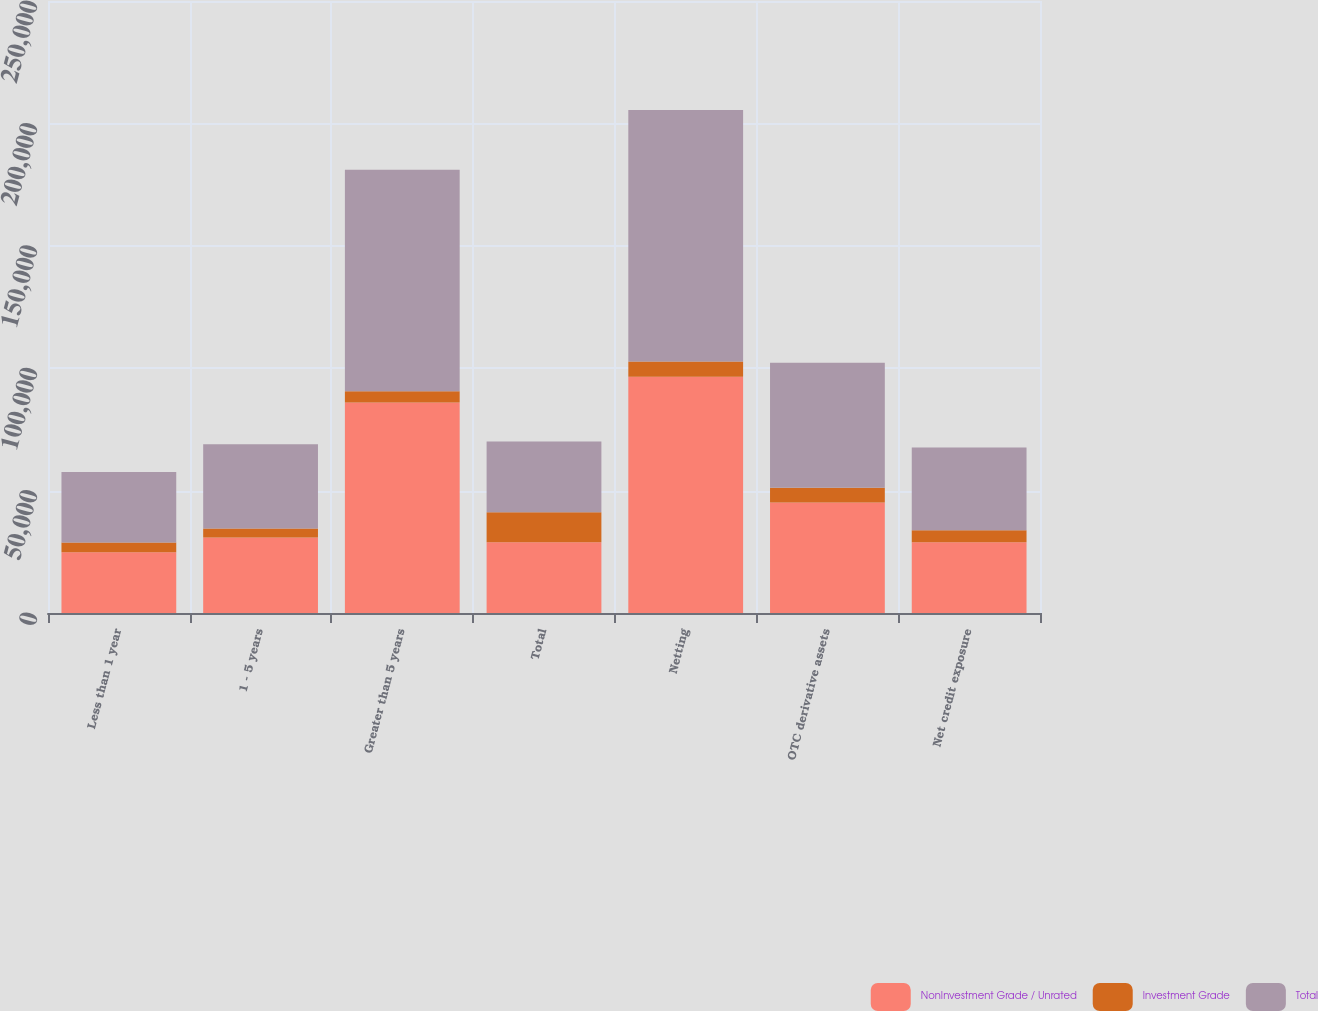Convert chart. <chart><loc_0><loc_0><loc_500><loc_500><stacked_bar_chart><ecel><fcel>Less than 1 year<fcel>1 - 5 years<fcel>Greater than 5 years<fcel>Total<fcel>Netting<fcel>OTC derivative assets<fcel>Net credit exposure<nl><fcel>NonInvestment Grade / Unrated<fcel>24840<fcel>30801<fcel>85951<fcel>28879<fcel>96493<fcel>45099<fcel>28879<nl><fcel>Investment Grade<fcel>3983<fcel>3676<fcel>4599<fcel>12258<fcel>6232<fcel>6026<fcel>4922<nl><fcel>Total<fcel>28823<fcel>34477<fcel>90550<fcel>28879<fcel>102725<fcel>51125<fcel>33801<nl></chart> 